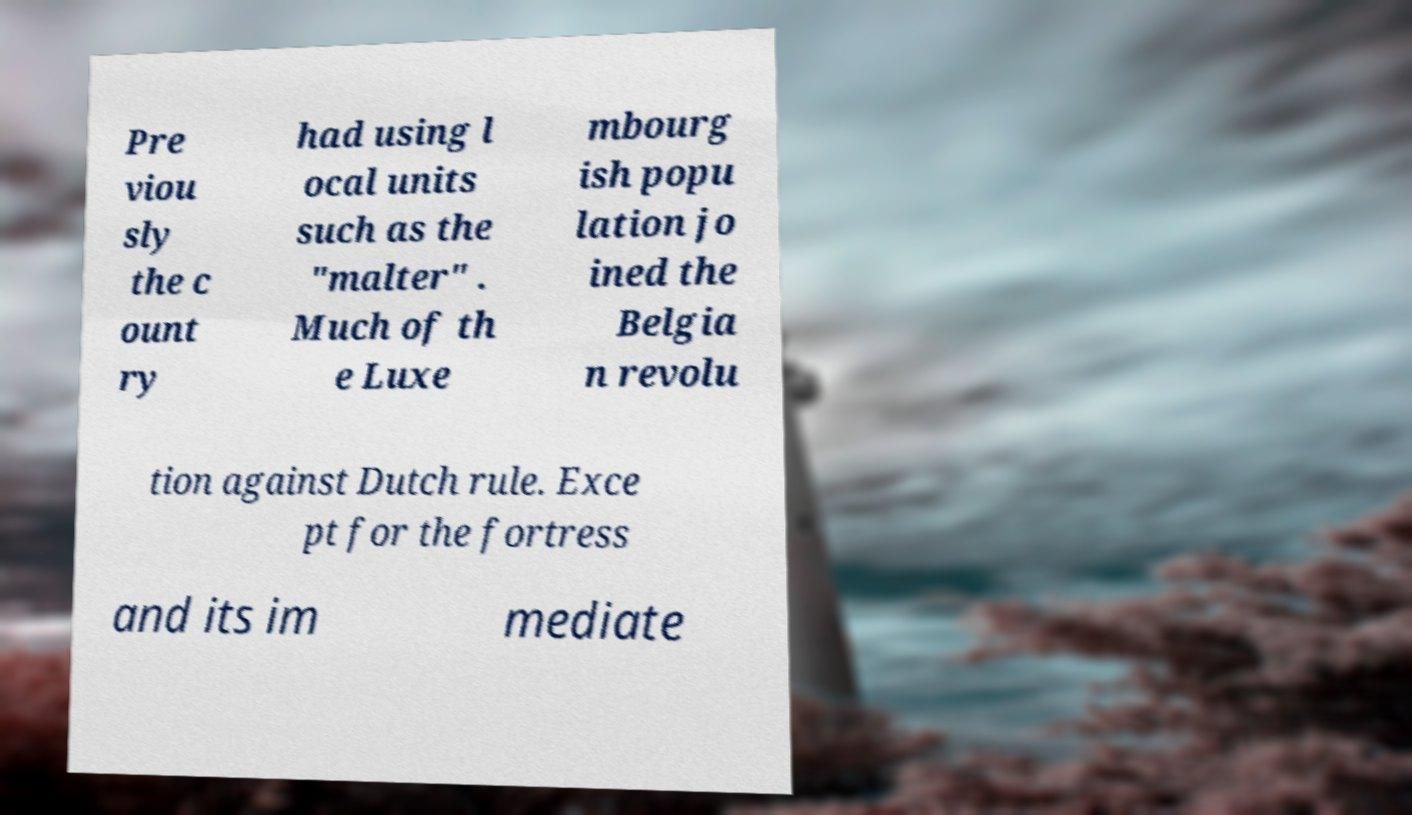Can you accurately transcribe the text from the provided image for me? Pre viou sly the c ount ry had using l ocal units such as the "malter" . Much of th e Luxe mbourg ish popu lation jo ined the Belgia n revolu tion against Dutch rule. Exce pt for the fortress and its im mediate 